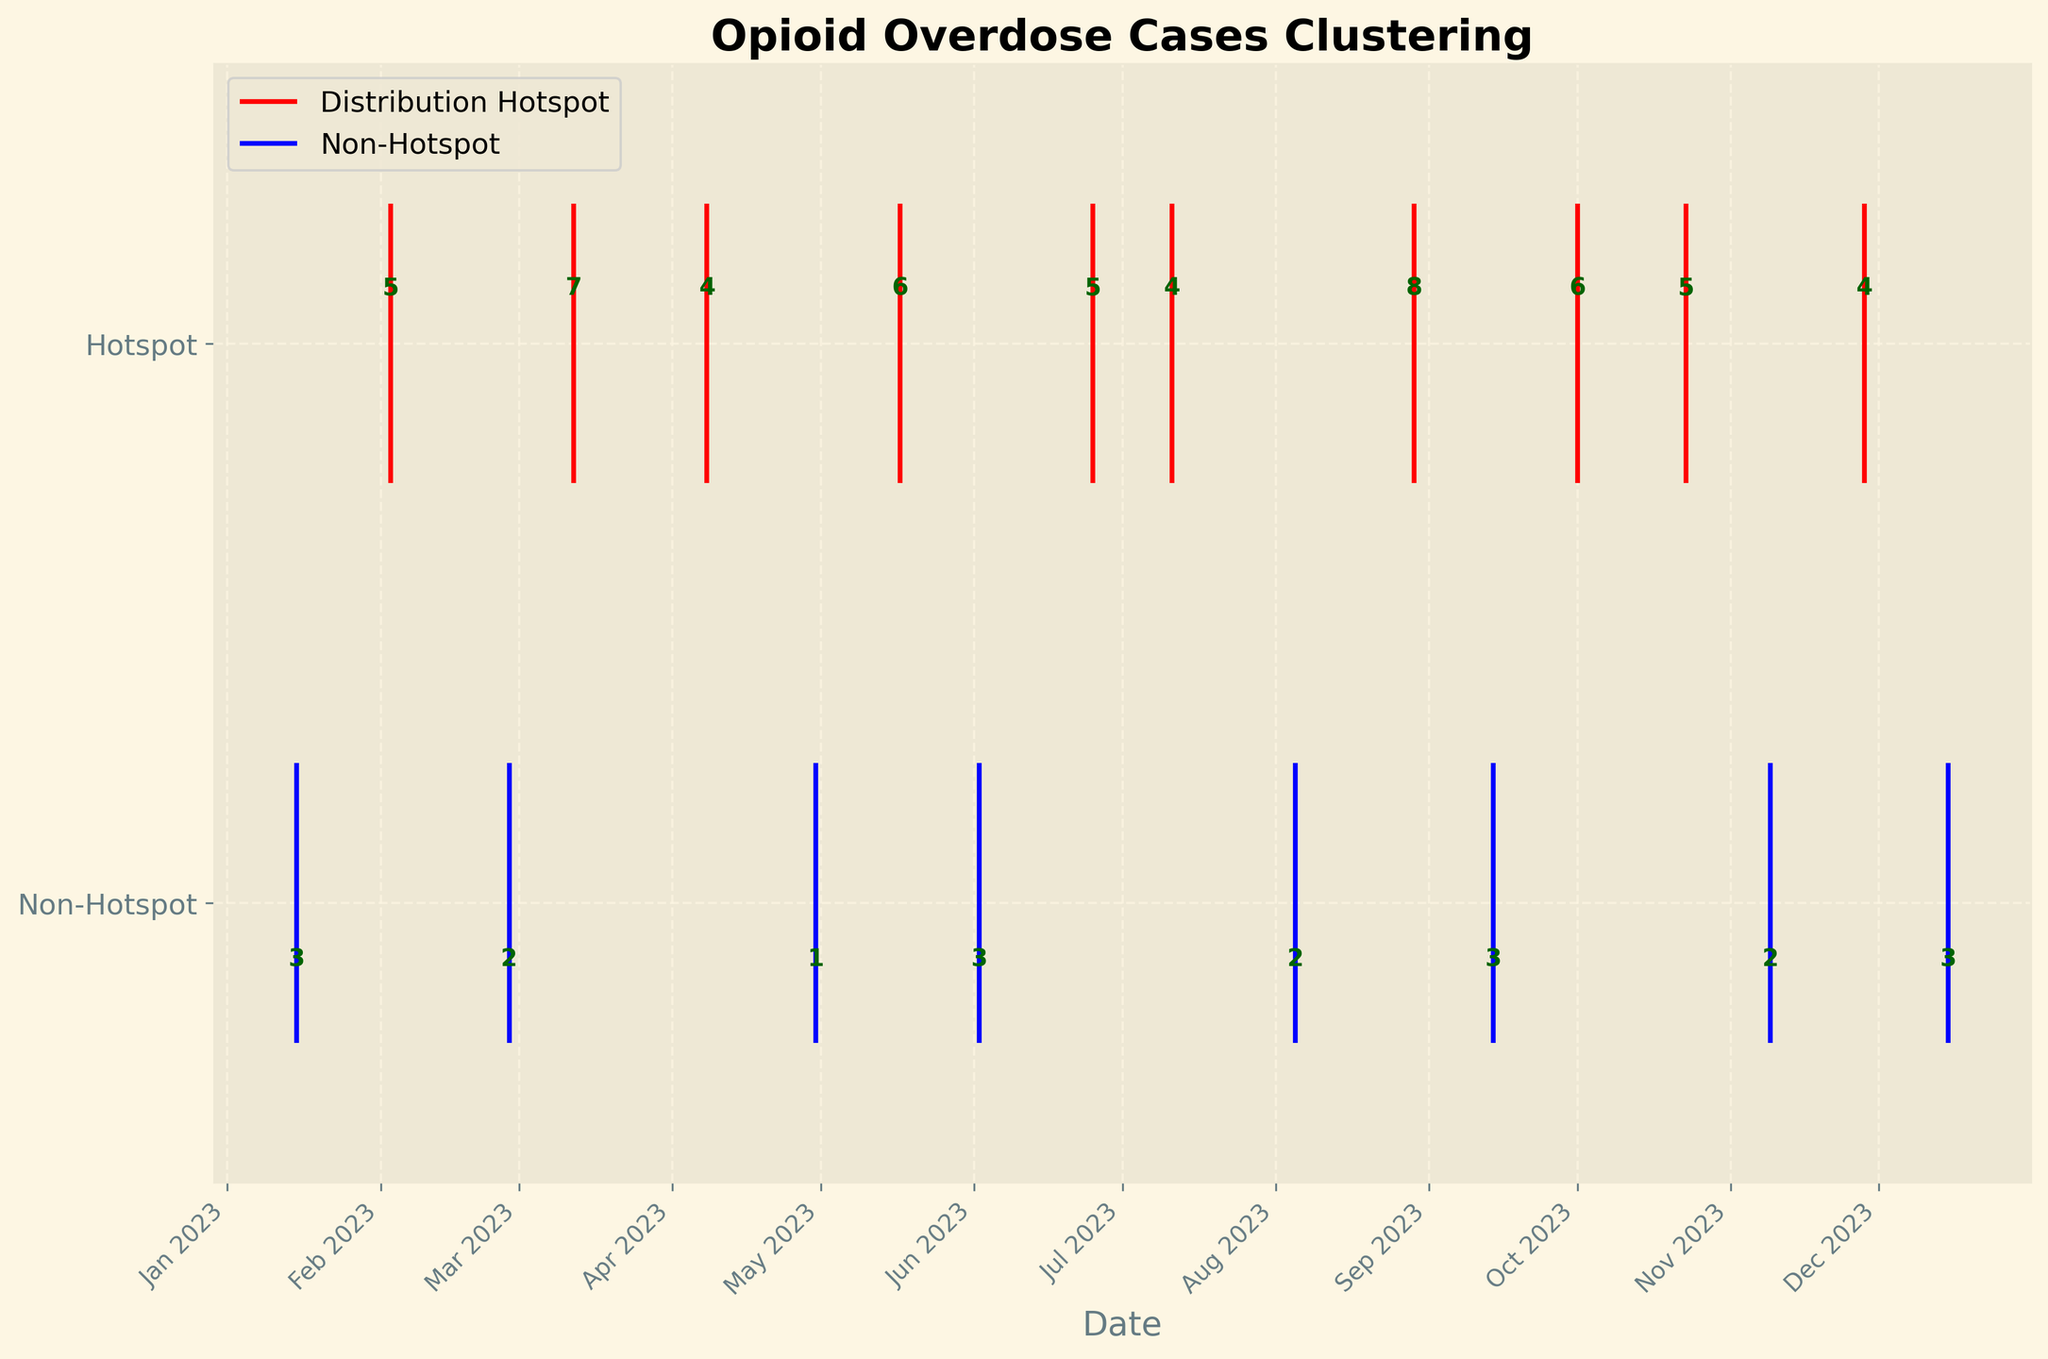What's the title of the plot? The title can be found at the top of the plot, written in larger, bold text. It describes the main subject of the plot.
Answer: Opioid Overdose Cases Clustering What do the y-axis labels represent? The y-axis labels can be found on the left-hand side of the plot. They indicate the categories that the data points represent.
Answer: Non-Hotspot and Hotspot How many data points represent non-hotspot locations? The blue lines represent non-hotspot locations. By counting the number of blue lines, we can determine the number of non-hotspot data points.
Answer: 8 How many overdose cases were reported in Bedford-Stuyvesant? The overdose count for each location is displayed as text near the data points on the plot. Look for the label near Bedford-Stuyvesant.
Answer: 8 Which month had the highest number of overdose clusters recorded? Look at the x-axis to find the months, and count the number of data points within each month to determine which month had the highest number of clusters.
Answer: August In which type of location (hotspot or non-hotspot) do most overdose cases occur? Compare the number of data points in the non-hotspot and hotspot categories by counting the red and blue lines respectively.
Answer: Hotspot What is the color used to represent distribution hotspots? The legend of the plot indicates the colors used for different categories. Look at the color next to "Distribution Hotspot".
Answer: Red What's the difference in the number of overdose cases between South Bronx and Central Park? The number of overdose cases for each location is shown next to the respective data points. Subtract the number of cases in Central Park from those in the South Bronx.
Answer: 3 Which distribution hotspot location had the most overdose cases? For each location listed as a distribution hotspot in red, compare the overdose case numbers noted near each data point to find the highest.
Answer: Bedford-Stuyvesant 